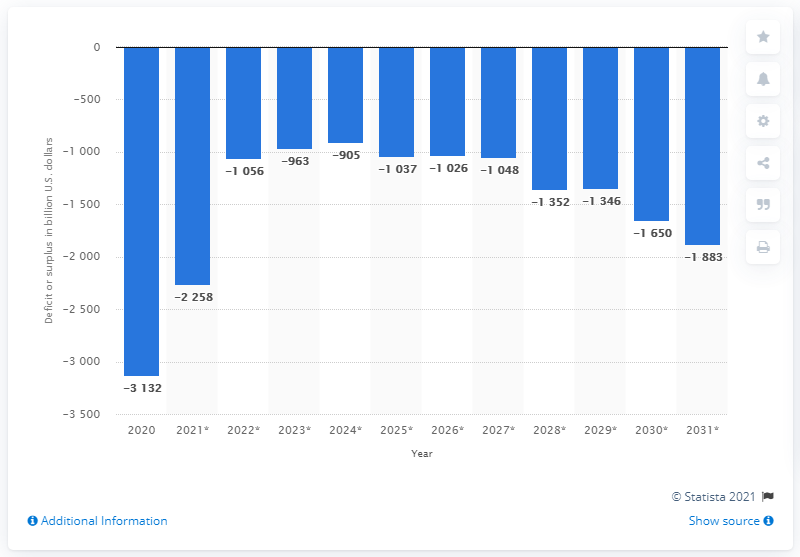Mention a couple of crucial points in this snapshot. The forecasted budget balance for the U.S. government is predicted to fluctuate between 2020 and beyond. 